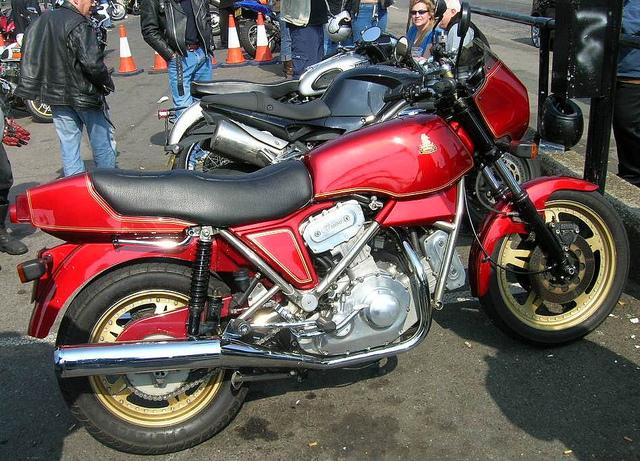Is this a big red bike?
Be succinct. Yes. How many orange cones are in the street?
Short answer required. 5. Could this be a biker meeting?
Short answer required. Yes. 